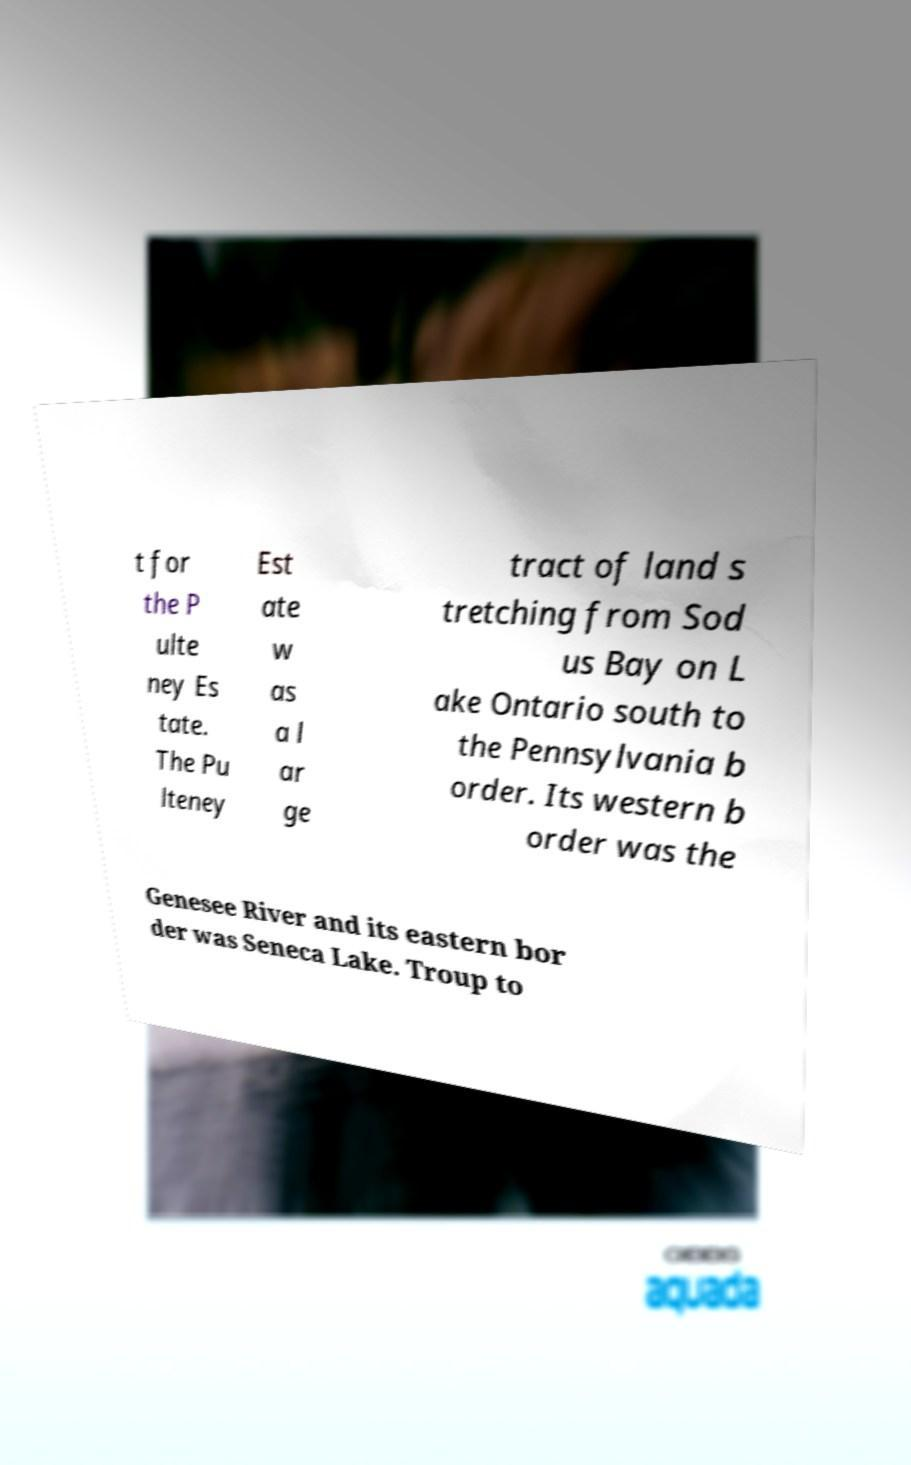Please read and relay the text visible in this image. What does it say? t for the P ulte ney Es tate. The Pu lteney Est ate w as a l ar ge tract of land s tretching from Sod us Bay on L ake Ontario south to the Pennsylvania b order. Its western b order was the Genesee River and its eastern bor der was Seneca Lake. Troup to 